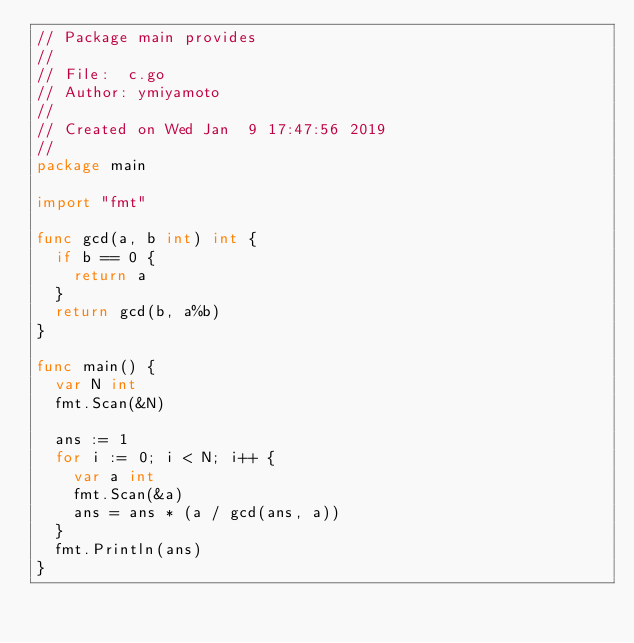<code> <loc_0><loc_0><loc_500><loc_500><_Go_>// Package main provides
//
// File:  c.go
// Author: ymiyamoto
//
// Created on Wed Jan  9 17:47:56 2019
//
package main

import "fmt"

func gcd(a, b int) int {
	if b == 0 {
		return a
	}
	return gcd(b, a%b)
}

func main() {
	var N int
	fmt.Scan(&N)

	ans := 1
	for i := 0; i < N; i++ {
		var a int
		fmt.Scan(&a)
		ans = ans * (a / gcd(ans, a))
	}
	fmt.Println(ans)
}
</code> 